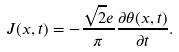Convert formula to latex. <formula><loc_0><loc_0><loc_500><loc_500>J ( x , t ) = - \frac { \sqrt { 2 } e } { \pi } \frac { \partial \theta ( x , t ) } { \partial t } .</formula> 